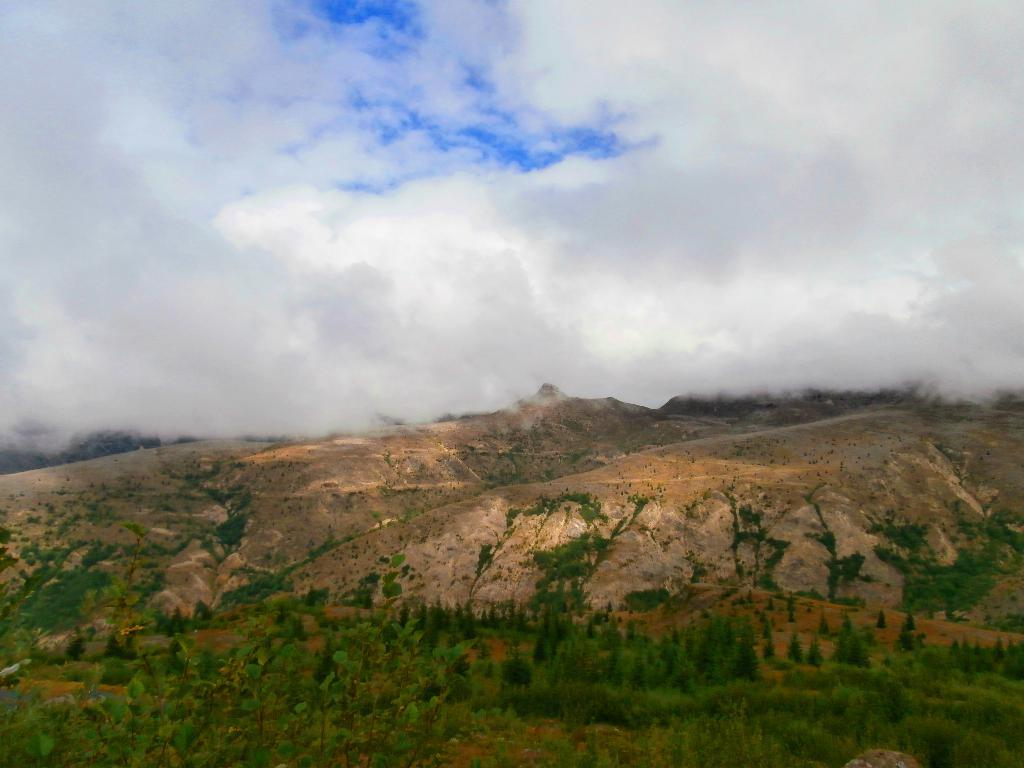What is the setting of the image? The image is an outside view. What can be seen at the bottom of the image? There are many trees and rocks at the bottom of the image. What is visible at the top of the image? The sky is visible at the top of the image. What can be observed in the sky? Clouds are present in the sky. What type of cheese is being used to create the circle in the image? There is no cheese or circle present in the image. What is the topic of the argument taking place in the image? There is no argument present in the image. 